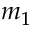<formula> <loc_0><loc_0><loc_500><loc_500>m _ { 1 }</formula> 